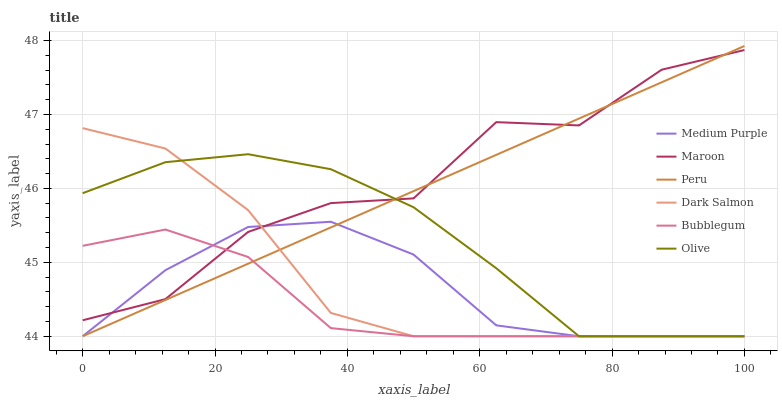Does Bubblegum have the minimum area under the curve?
Answer yes or no. Yes. Does Maroon have the maximum area under the curve?
Answer yes or no. Yes. Does Medium Purple have the minimum area under the curve?
Answer yes or no. No. Does Medium Purple have the maximum area under the curve?
Answer yes or no. No. Is Peru the smoothest?
Answer yes or no. Yes. Is Maroon the roughest?
Answer yes or no. Yes. Is Bubblegum the smoothest?
Answer yes or no. No. Is Bubblegum the roughest?
Answer yes or no. No. Does Maroon have the lowest value?
Answer yes or no. No. Does Peru have the highest value?
Answer yes or no. Yes. Does Medium Purple have the highest value?
Answer yes or no. No. Does Medium Purple intersect Olive?
Answer yes or no. Yes. Is Medium Purple less than Olive?
Answer yes or no. No. Is Medium Purple greater than Olive?
Answer yes or no. No. 